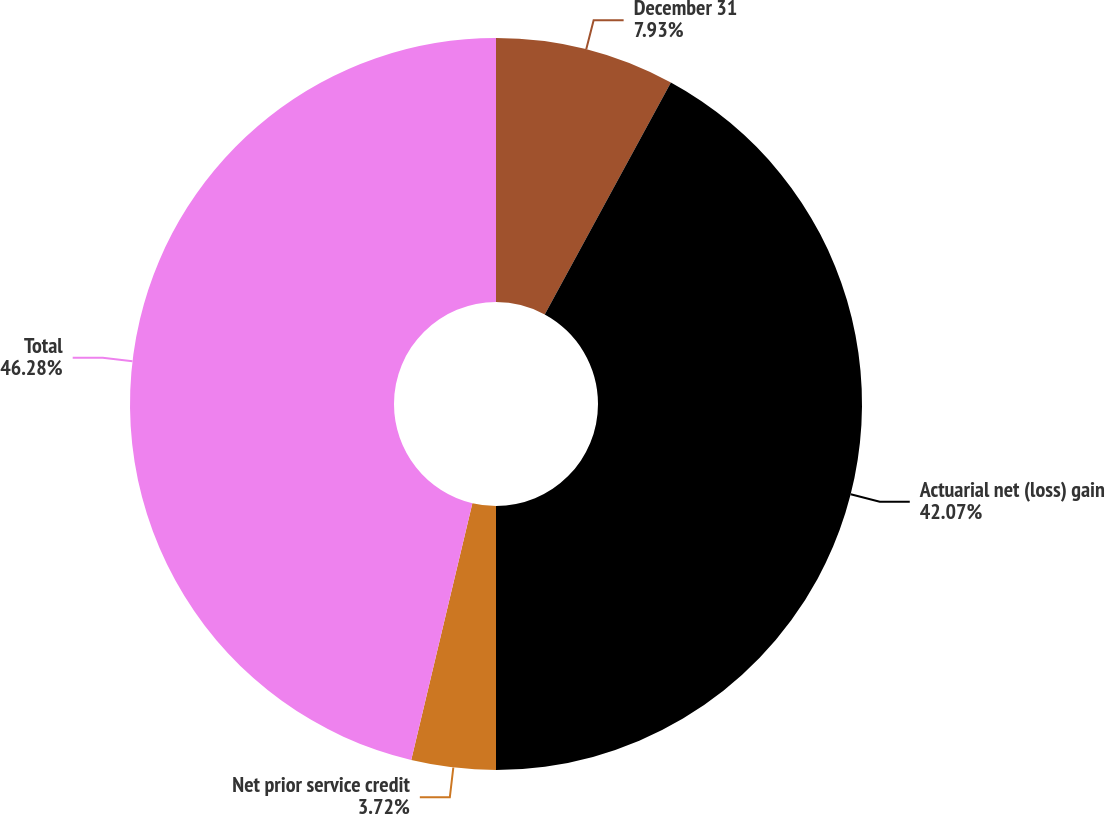Convert chart to OTSL. <chart><loc_0><loc_0><loc_500><loc_500><pie_chart><fcel>December 31<fcel>Actuarial net (loss) gain<fcel>Net prior service credit<fcel>Total<nl><fcel>7.93%<fcel>42.07%<fcel>3.72%<fcel>46.28%<nl></chart> 